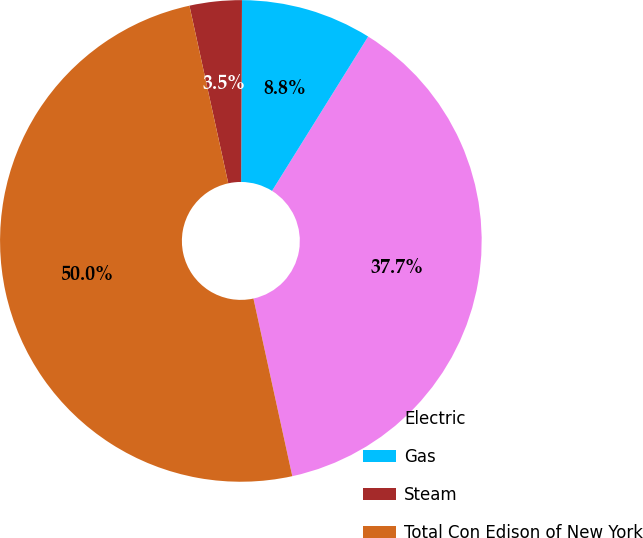<chart> <loc_0><loc_0><loc_500><loc_500><pie_chart><fcel>Electric<fcel>Gas<fcel>Steam<fcel>Total Con Edison of New York<nl><fcel>37.71%<fcel>8.79%<fcel>3.5%<fcel>50.0%<nl></chart> 